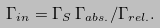Convert formula to latex. <formula><loc_0><loc_0><loc_500><loc_500>\Gamma _ { i n } = \Gamma _ { S } \, \Gamma _ { a b s . } / \Gamma _ { r e l . } .</formula> 